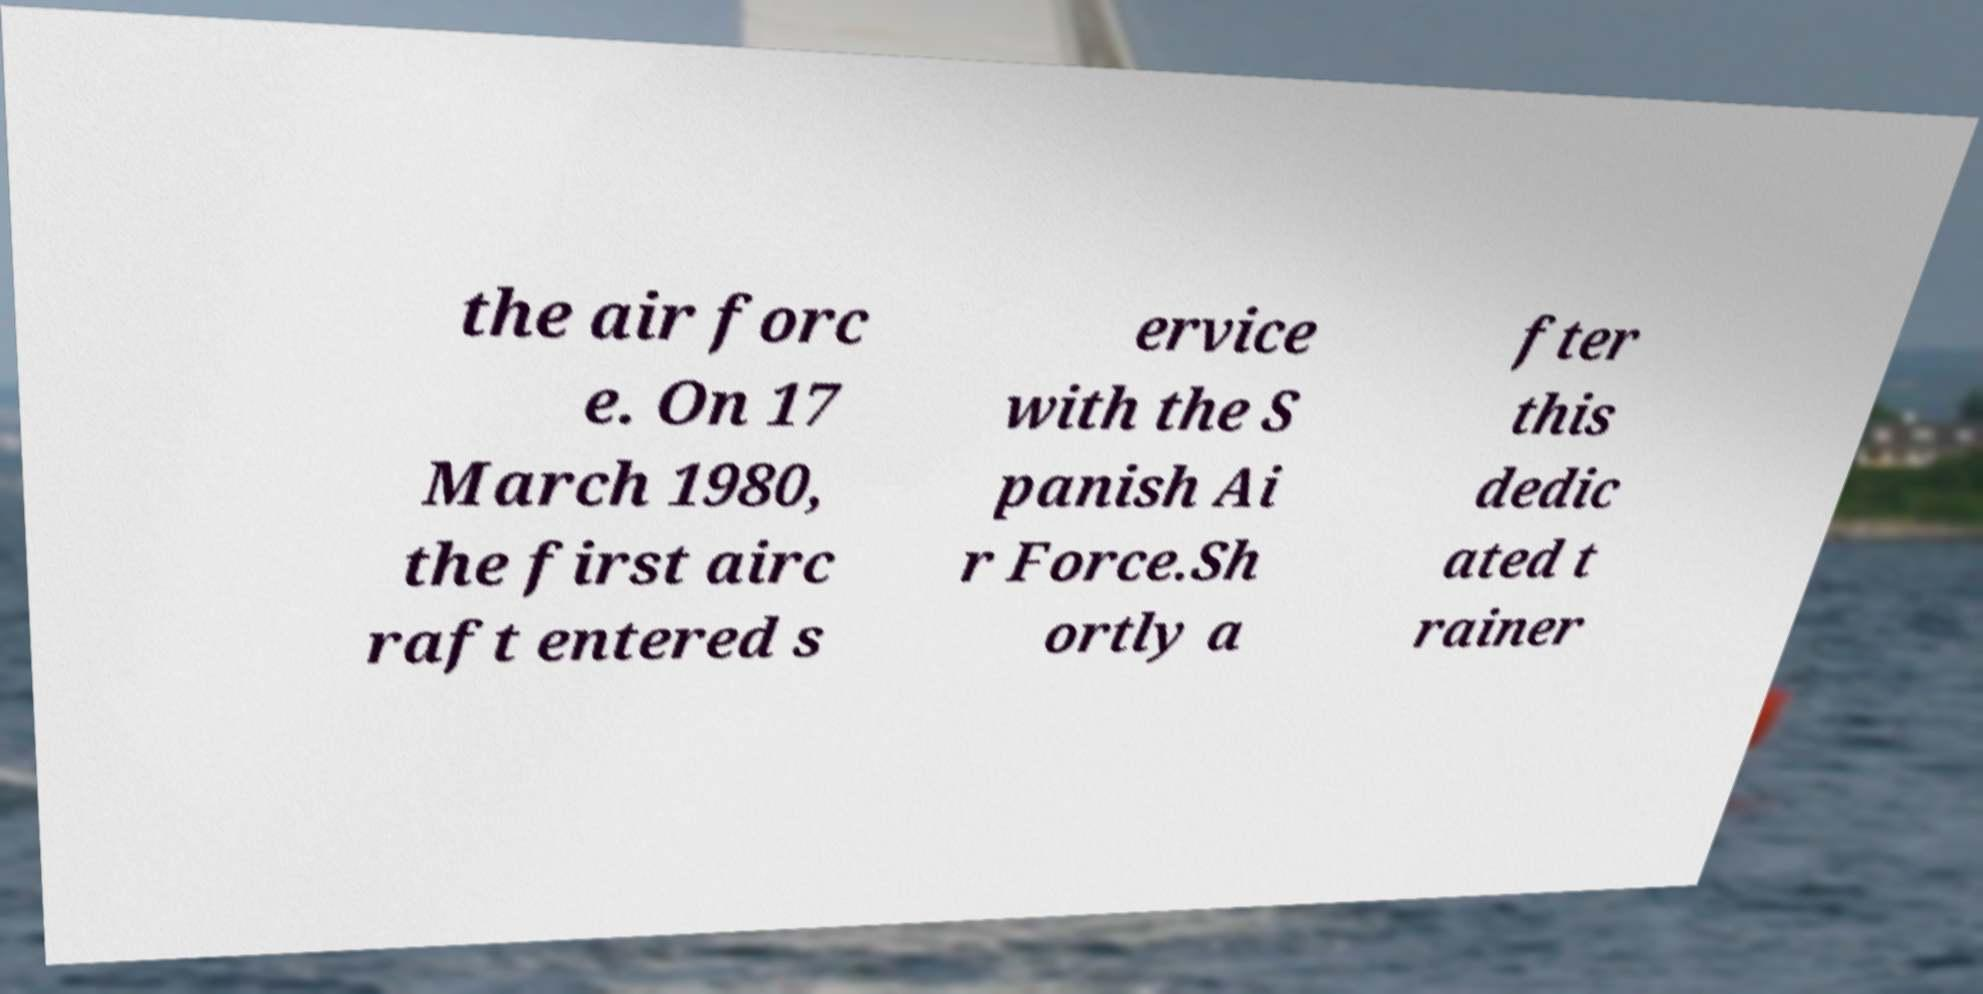Please read and relay the text visible in this image. What does it say? the air forc e. On 17 March 1980, the first airc raft entered s ervice with the S panish Ai r Force.Sh ortly a fter this dedic ated t rainer 